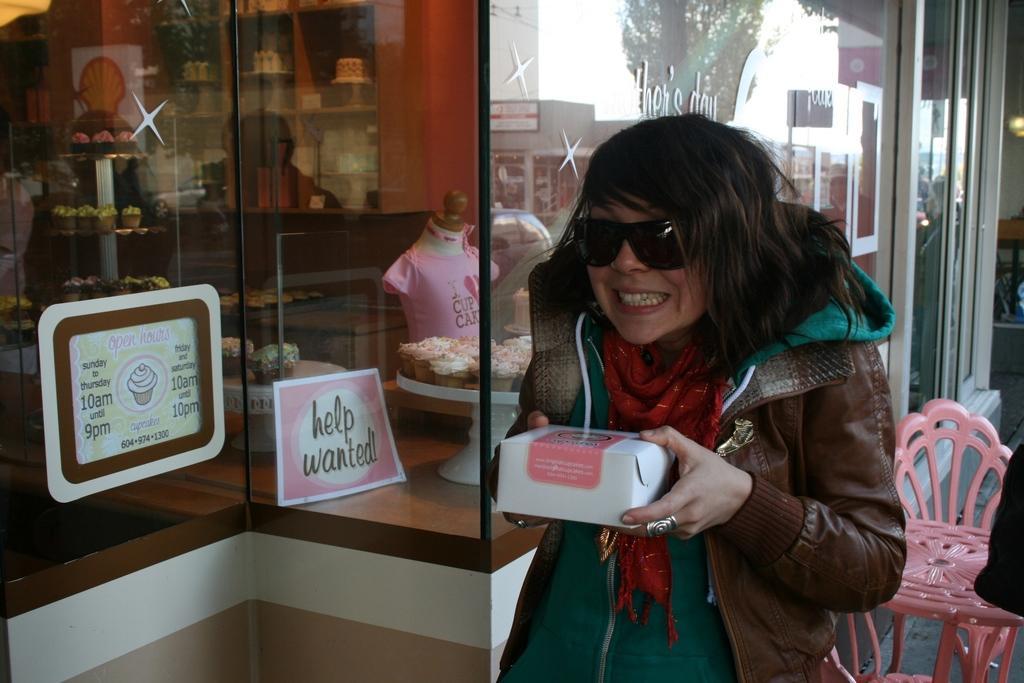Can you describe this image briefly? In the image there is a lady standing and holding the box in the hand and she kept goggles. Behind her there is a table and a chair. And also there are glass walls with something written on it and also there is a poster. And also there are glass doors. Behind the glass there are tables with cupcakes and many other items inside the store. 